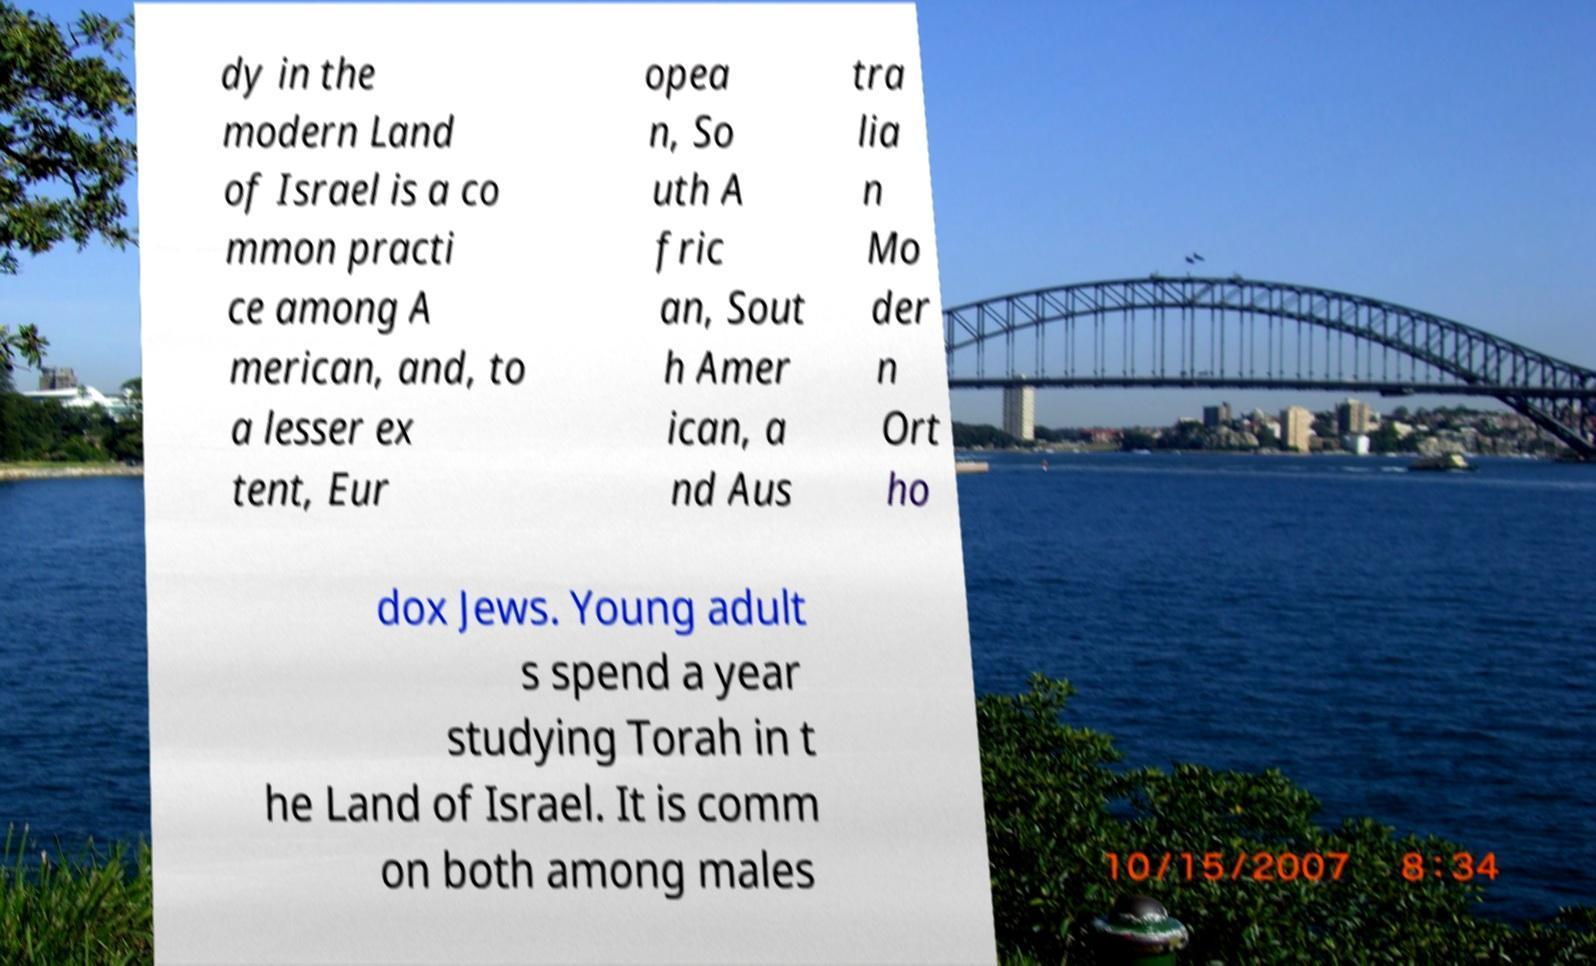Please read and relay the text visible in this image. What does it say? dy in the modern Land of Israel is a co mmon practi ce among A merican, and, to a lesser ex tent, Eur opea n, So uth A fric an, Sout h Amer ican, a nd Aus tra lia n Mo der n Ort ho dox Jews. Young adult s spend a year studying Torah in t he Land of Israel. It is comm on both among males 